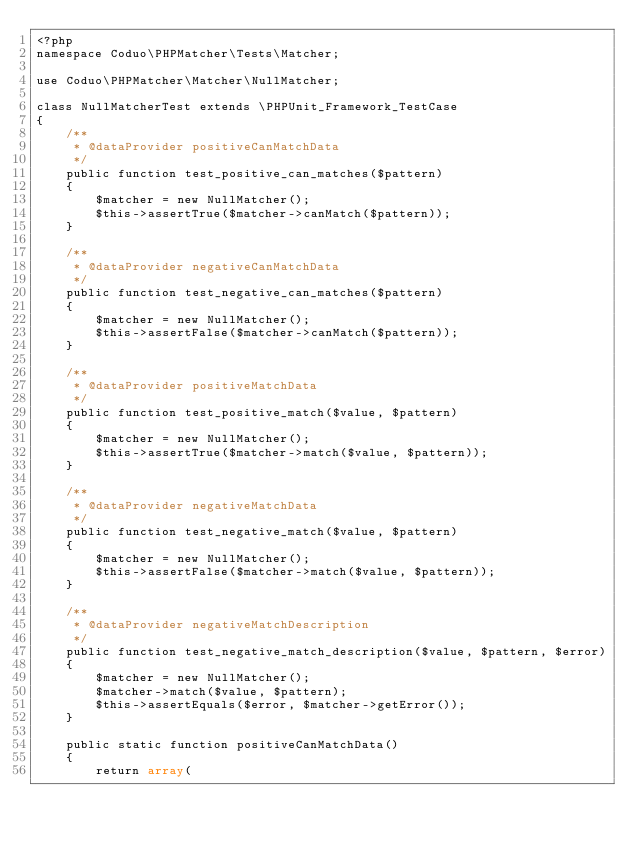Convert code to text. <code><loc_0><loc_0><loc_500><loc_500><_PHP_><?php
namespace Coduo\PHPMatcher\Tests\Matcher;

use Coduo\PHPMatcher\Matcher\NullMatcher;

class NullMatcherTest extends \PHPUnit_Framework_TestCase
{
    /**
     * @dataProvider positiveCanMatchData
     */
    public function test_positive_can_matches($pattern)
    {
        $matcher = new NullMatcher();
        $this->assertTrue($matcher->canMatch($pattern));
    }

    /**
     * @dataProvider negativeCanMatchData
     */
    public function test_negative_can_matches($pattern)
    {
        $matcher = new NullMatcher();
        $this->assertFalse($matcher->canMatch($pattern));
    }

    /**
     * @dataProvider positiveMatchData
     */
    public function test_positive_match($value, $pattern)
    {
        $matcher = new NullMatcher();
        $this->assertTrue($matcher->match($value, $pattern));
    }

    /**
     * @dataProvider negativeMatchData
     */
    public function test_negative_match($value, $pattern)
    {
        $matcher = new NullMatcher();
        $this->assertFalse($matcher->match($value, $pattern));
    }

    /**
     * @dataProvider negativeMatchDescription
     */
    public function test_negative_match_description($value, $pattern, $error)
    {
        $matcher = new NullMatcher();
        $matcher->match($value, $pattern);
        $this->assertEquals($error, $matcher->getError());
    }

    public static function positiveCanMatchData()
    {
        return array(</code> 